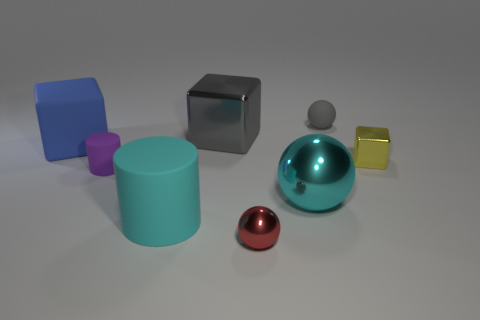Add 2 big cyan objects. How many objects exist? 10 Subtract all cylinders. How many objects are left? 6 Add 7 large brown balls. How many large brown balls exist? 7 Subtract 0 blue balls. How many objects are left? 8 Subtract all large blue objects. Subtract all big blue matte blocks. How many objects are left? 6 Add 5 rubber spheres. How many rubber spheres are left? 6 